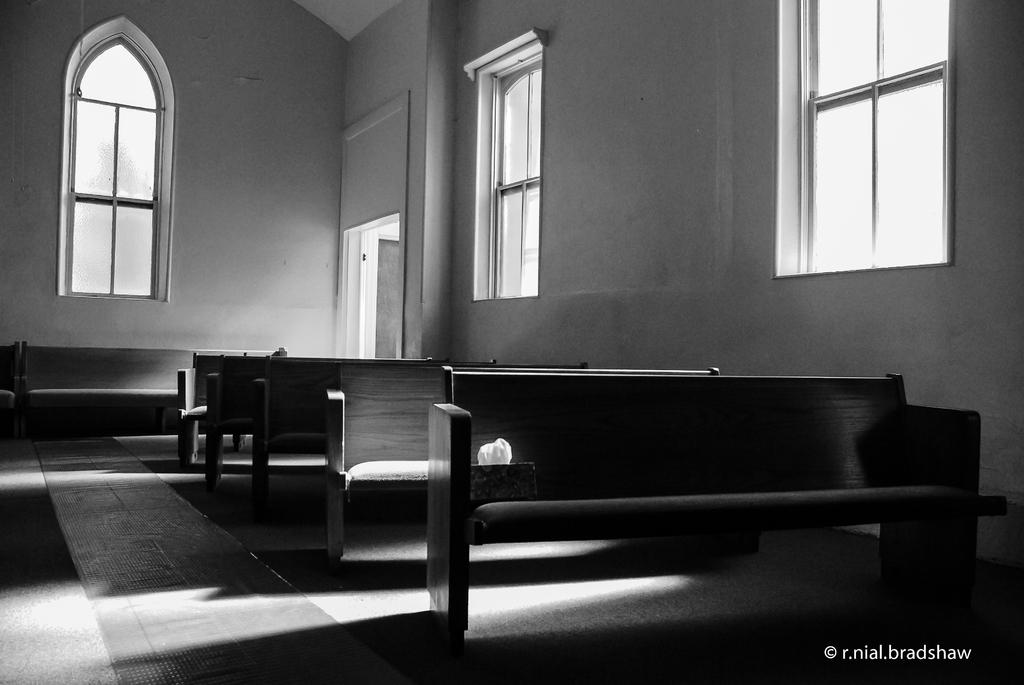What type of setting is shown in the image? The image depicts an inside view of a classroom. What can be seen at the front of the classroom? There are wooden benches in the front of the classroom. What is the appearance of the wall behind the benches? There is a white wall with a glass window behind the benches. How many pages are visible on the desk in the image? There is no desk present in the image, so it is not possible to determine the number of pages. 